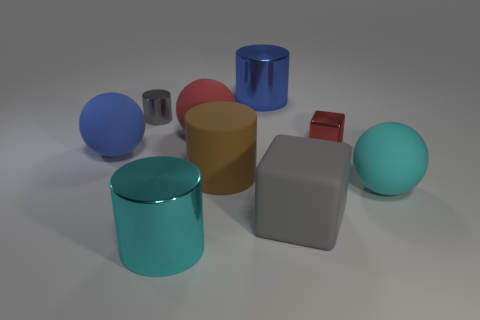Are there any other things that are the same size as the red metal cube?
Provide a succinct answer. Yes. What is the shape of the blue object that is right of the big metal cylinder that is in front of the cyan ball?
Ensure brevity in your answer.  Cylinder. Do the small thing that is on the right side of the tiny cylinder and the large cyan object that is to the left of the large brown rubber thing have the same material?
Keep it short and to the point. Yes. What number of spheres are left of the ball on the left side of the cyan cylinder?
Your answer should be very brief. 0. There is a small object that is on the right side of the large blue metallic cylinder; is its shape the same as the cyan object behind the big cyan shiny object?
Ensure brevity in your answer.  No. How big is the matte object that is behind the big brown rubber cylinder and right of the cyan cylinder?
Provide a short and direct response. Large. There is a small metallic thing that is the same shape as the big brown thing; what is its color?
Provide a short and direct response. Gray. There is a cube that is in front of the cube behind the brown object; what is its color?
Your answer should be compact. Gray. What shape is the big red matte object?
Keep it short and to the point. Sphere. There is a thing that is left of the cyan shiny object and behind the tiny red object; what is its shape?
Your response must be concise. Cylinder. 